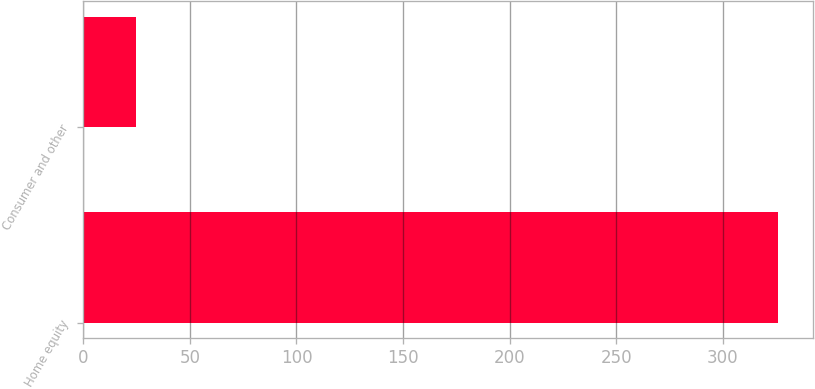Convert chart. <chart><loc_0><loc_0><loc_500><loc_500><bar_chart><fcel>Home equity<fcel>Consumer and other<nl><fcel>326.1<fcel>24.7<nl></chart> 